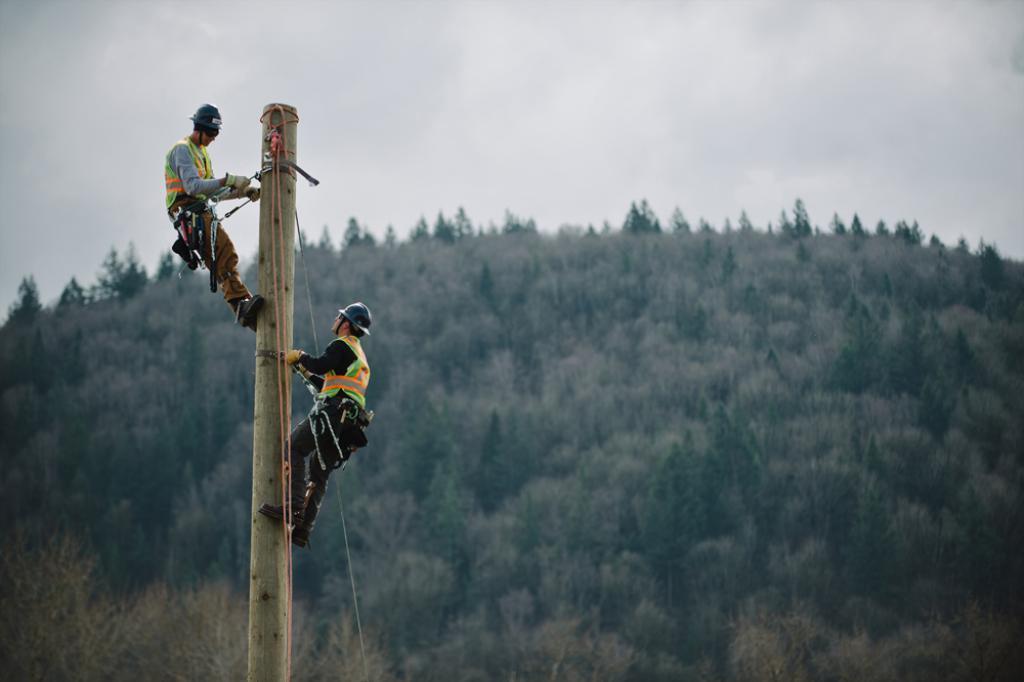How would you summarize this image in a sentence or two? This picture is clicked outside. On the left we can see the two persons wearing helmets and standing on the wooden pole and the two persons are tied with the ropes. In the background we can see the sky and the trees. 